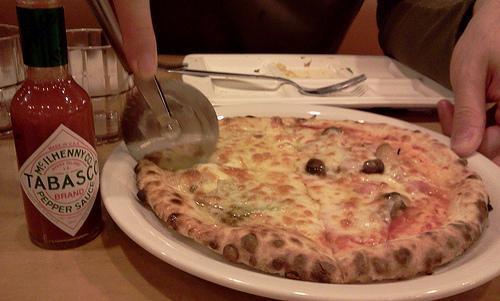How many pizzas are in the scene?
Give a very brief answer. 1. 